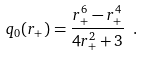Convert formula to latex. <formula><loc_0><loc_0><loc_500><loc_500>q _ { 0 } ( r _ { + } ) = { \frac { r _ { + } ^ { 6 } - r _ { + } ^ { 4 } } { 4 r _ { + } ^ { 2 } + 3 } } \ .</formula> 